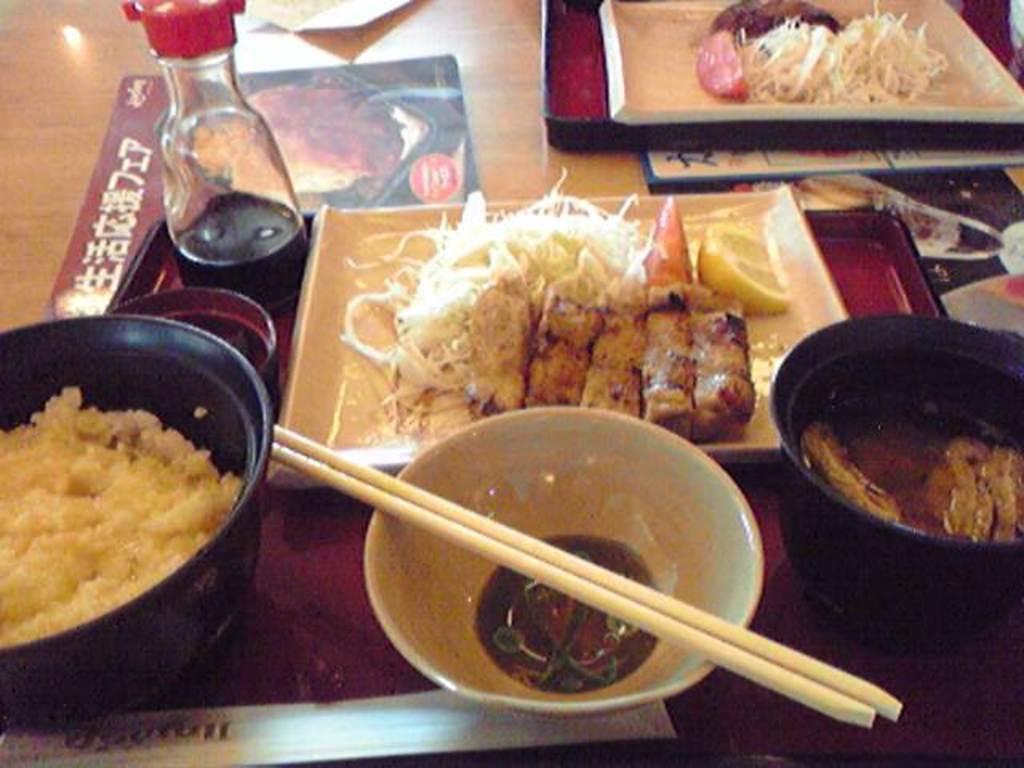Could you give a brief overview of what you see in this image? In this picture there is a bowl, chopsticks, bottle, food in the plate. There is a table. There is a paper. 